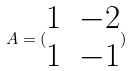<formula> <loc_0><loc_0><loc_500><loc_500>A = ( \begin{matrix} 1 & - 2 \\ 1 & - 1 \end{matrix} )</formula> 